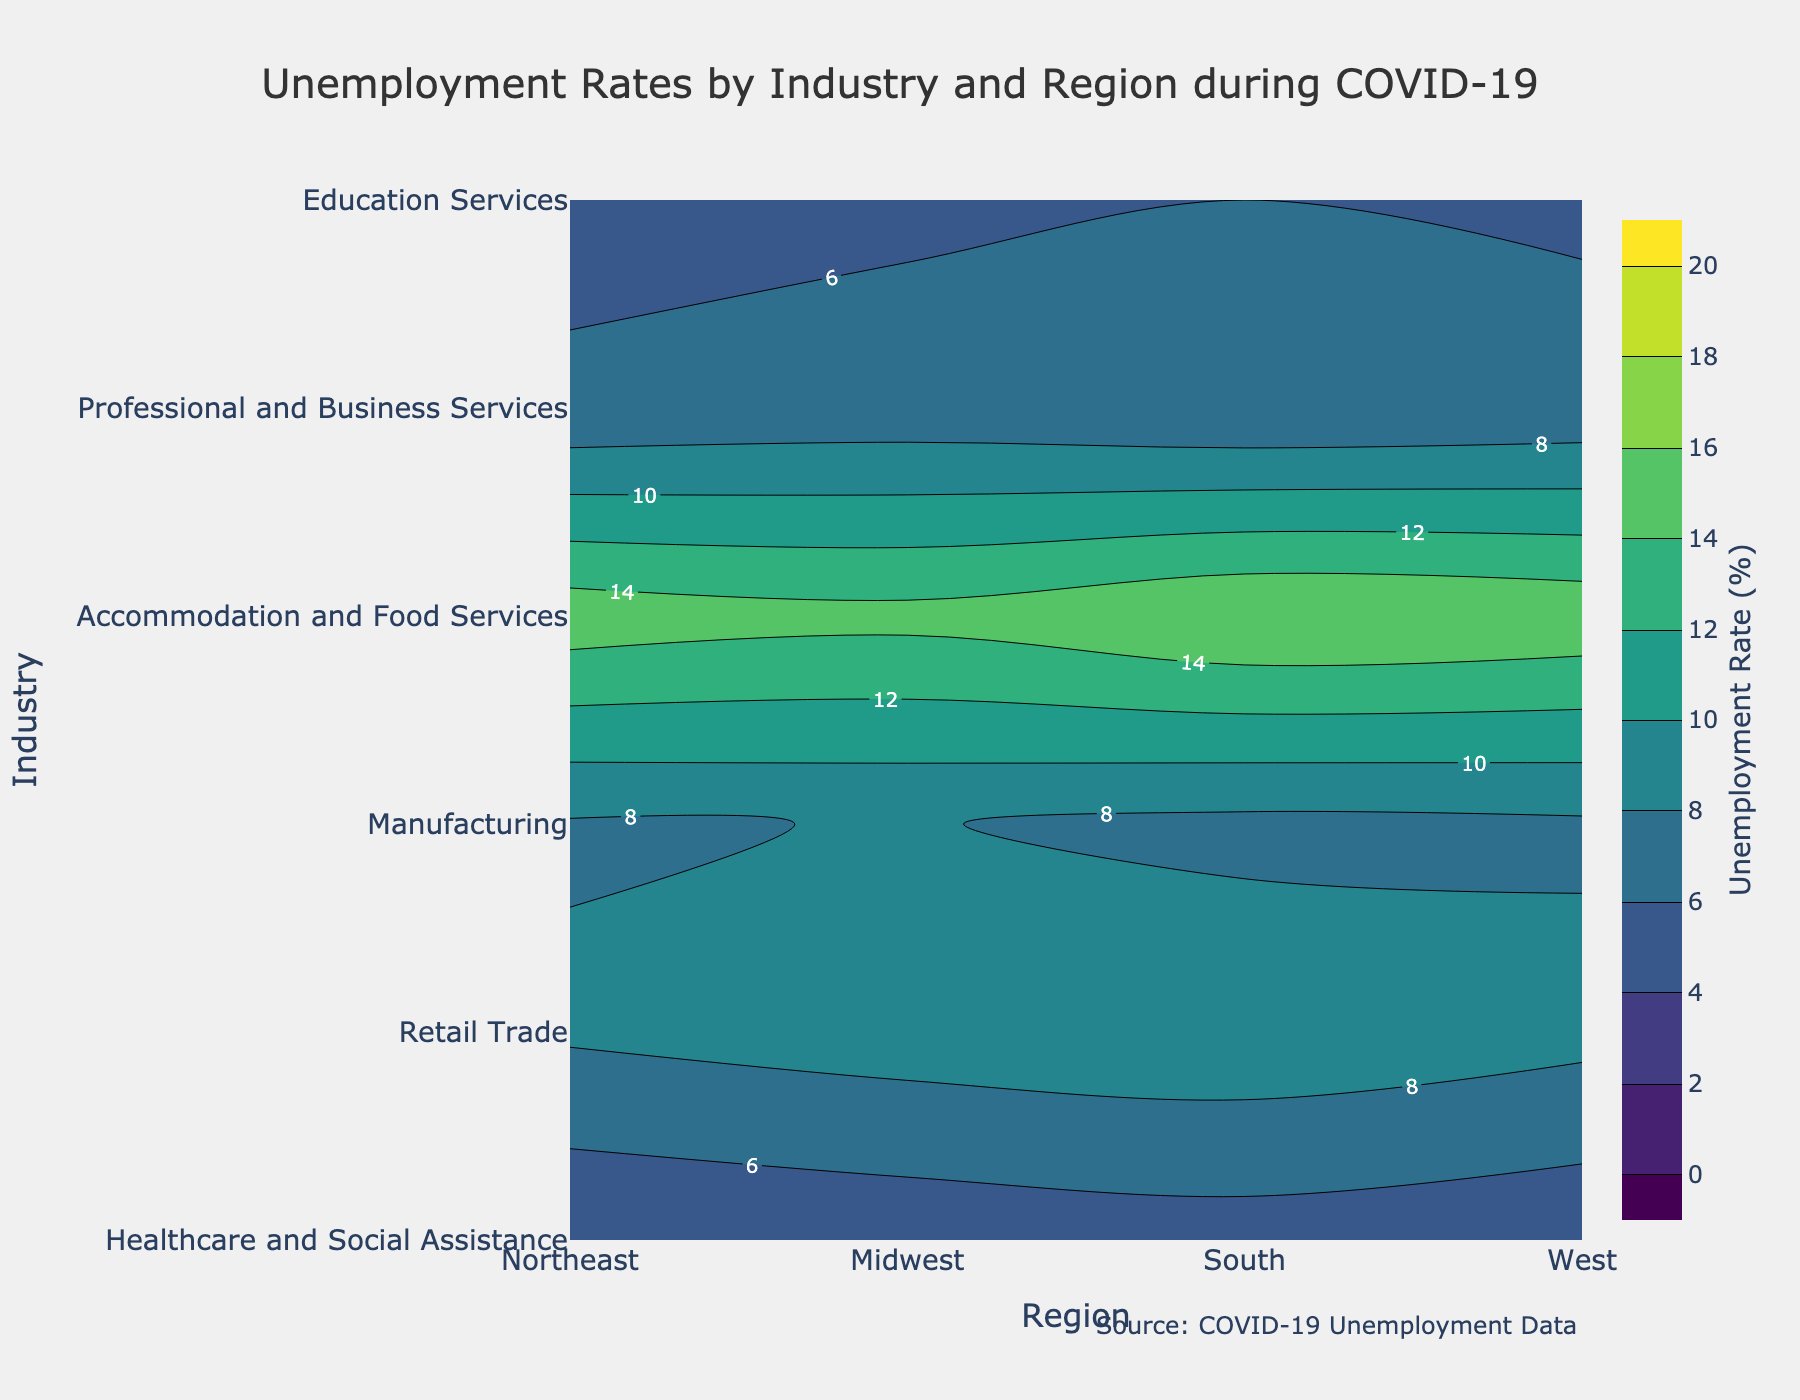What's the unemployment rate for the Retail Trade industry in the Midwest region? Locate the intersection of the "Retail Trade" row and "Midwest" column. The contour indicates the unemployment rate.
Answer: 9.0% What is the difference in unemployment rates between the Healthcare and Social Assistance industry in the South and the Midwest? Find the unemployment rates for "Healthcare and Social Assistance" in "South" (5.1%) and "Midwest" (4.7%), then subtract the Midwest value from South. 5.1% - 4.7% = 0.4%
Answer: 0.4% Which industry experienced the highest unemployment rate in the Northeast region? Identify the highest contour value in the "Northeast" column. The highest value is for "Accommodation and Food Services" at 15.2%.
Answer: Accommodation and Food Services On average, which region had the highest unemployment rate across all industries? Calculate the average unemployment rate for each region: 
Northeast: (4.2 + 8.3 + 7.8 + 15.2 + 6.3 + 5.5) / 6 = 7.88
Midwest: (4.7 + 9.0 + 8.1 + 14.6 + 6.7 + 5.7) / 6 = 8.15
South: (5.1 + 9.4 + 7.5 + 16.0 + 6.1 + 6.0) / 6 = 8.35
West: (4.5 + 8.6 + 7.7 + 15.5 + 6.5 + 5.8) / 6 = 8.1
The South has the highest average unemployment rate: 8.35
Answer: South Were the unemployment rates higher for Retail Trade or Manufacturing in the West region? Compare the unemployment rates in the "West" column for "Retail Trade" (8.6) and "Manufacturing" (7.7). "Retail Trade" has a higher rate.
Answer: Retail Trade How does the unemployment rate in Professional and Business Services in the Midwest compare to the South? Find the unemployment rates for "Professional and Business Services" in "Midwest" (6.7%) and "South" (6.1%). The rate is higher in the Midwest.
Answer: Higher in Midwest Does the Education Services industry show more variation in unemployment rates across regions compared to Healthcare and Social Assistance? Compare the range of unemployment rates for "Education Services" (5.5 to 6.0) and "Healthcare and Social Assistance" (4.2 to 5.1). The range for Educational Services is narrower than for Healthcare and Social Assistance, indicating less variation.
Answer: No Is there any region where the Manufacturing industry had a lower unemployment rate than the Retail Trade industry? Compare the unemployment rates for "Manufacturing" and "Retail Trade" across all regions:
Northeast: Manufacturing (7.8) < Retail Trade (8.3)
Midwest: Manufacturing (8.1) < Retail Trade (9.0)
South: Manufacturing (7.5) < Retail Trade (9.4)
West: Manufacturing (7.7) < Retail Trade (8.6)
In all regions, Manufacturing had a lower unemployment rate than Retail Trade.
Answer: Yes What was the unemployment rate for Accommodation and Food Services in the West region? Locate the intersection of "Accommodation and Food Services" row and "West" column. The contour indicates the unemployment rate, which is 15.5%.
Answer: 15.5% 